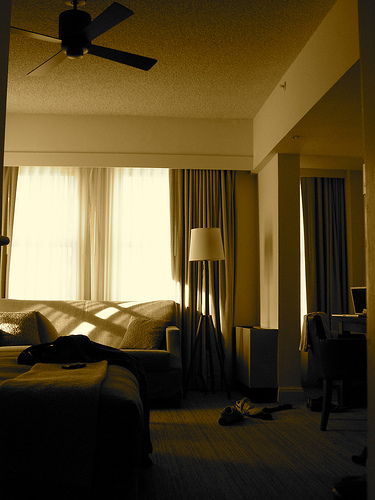<image>
Is the lamp next to the couch? Yes. The lamp is positioned adjacent to the couch, located nearby in the same general area. Is the lamp in front of the curtain? Yes. The lamp is positioned in front of the curtain, appearing closer to the camera viewpoint. 